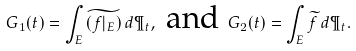Convert formula to latex. <formula><loc_0><loc_0><loc_500><loc_500>G _ { 1 } ( t ) = \int _ { E } \widetilde { ( f | _ { E } ) } \, d \P _ { t } , \text { and } G _ { 2 } ( t ) = \int _ { E } \widetilde { f } \, d \P _ { t } .</formula> 